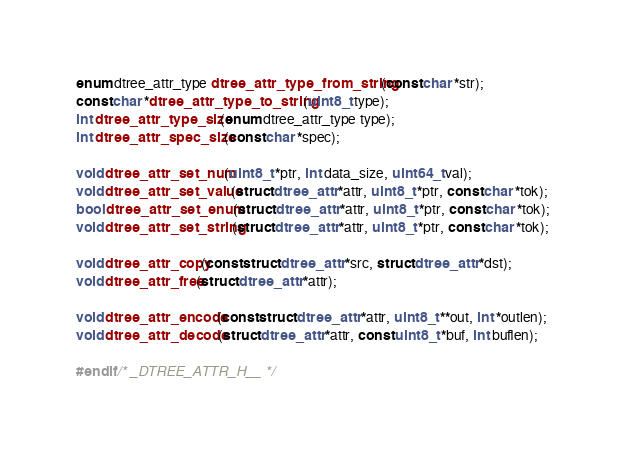Convert code to text. <code><loc_0><loc_0><loc_500><loc_500><_C_>
enum dtree_attr_type dtree_attr_type_from_string(const char *str);
const char *dtree_attr_type_to_string(uint8_t type);
int dtree_attr_type_size(enum dtree_attr_type type);
int dtree_attr_spec_size(const char *spec);

void dtree_attr_set_num(uint8_t *ptr, int data_size, uint64_t val);
void dtree_attr_set_value(struct dtree_attr *attr, uint8_t *ptr, const char *tok);
bool dtree_attr_set_enum(struct dtree_attr *attr, uint8_t *ptr, const char *tok);
void dtree_attr_set_string(struct dtree_attr *attr, uint8_t *ptr, const char *tok);

void dtree_attr_copy(const struct dtree_attr *src, struct dtree_attr *dst);
void dtree_attr_free(struct dtree_attr *attr);

void dtree_attr_encode(const struct dtree_attr *attr, uint8_t **out, int *outlen);
void dtree_attr_decode(struct dtree_attr *attr, const uint8_t *buf, int buflen);

#endif /* _DTREE_ATTR_H__ */
</code> 